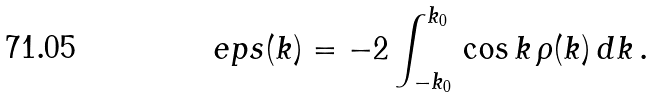<formula> <loc_0><loc_0><loc_500><loc_500>\ e p s ( k ) = - 2 \int _ { - k _ { 0 } } ^ { k _ { 0 } } \, \cos k \, \rho ( k ) \, d k \, .</formula> 